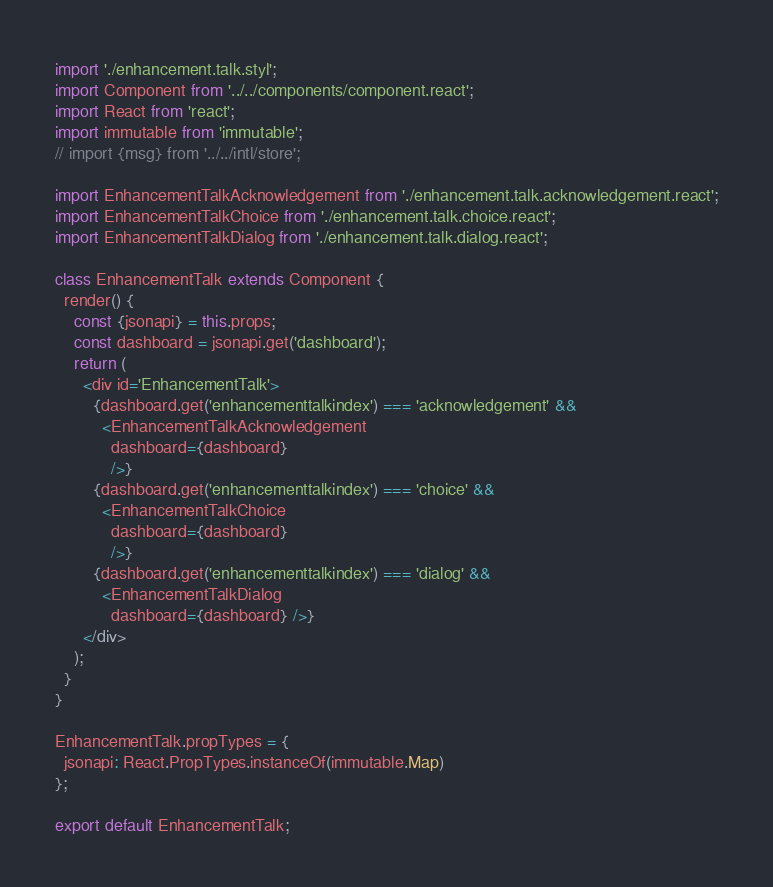<code> <loc_0><loc_0><loc_500><loc_500><_JavaScript_>import './enhancement.talk.styl';
import Component from '../../components/component.react';
import React from 'react';
import immutable from 'immutable';
// import {msg} from '../../intl/store';

import EnhancementTalkAcknowledgement from './enhancement.talk.acknowledgement.react';
import EnhancementTalkChoice from './enhancement.talk.choice.react';
import EnhancementTalkDialog from './enhancement.talk.dialog.react';

class EnhancementTalk extends Component {
  render() {
    const {jsonapi} = this.props;
    const dashboard = jsonapi.get('dashboard');
    return (
      <div id='EnhancementTalk'>
        {dashboard.get('enhancementtalkindex') === 'acknowledgement' &&
          <EnhancementTalkAcknowledgement
            dashboard={dashboard}
            />}
        {dashboard.get('enhancementtalkindex') === 'choice' &&
          <EnhancementTalkChoice
            dashboard={dashboard}
            />}
        {dashboard.get('enhancementtalkindex') === 'dialog' &&
          <EnhancementTalkDialog
            dashboard={dashboard} />}
      </div>
    );
  }
}

EnhancementTalk.propTypes = {
  jsonapi: React.PropTypes.instanceOf(immutable.Map)
};

export default EnhancementTalk;
</code> 